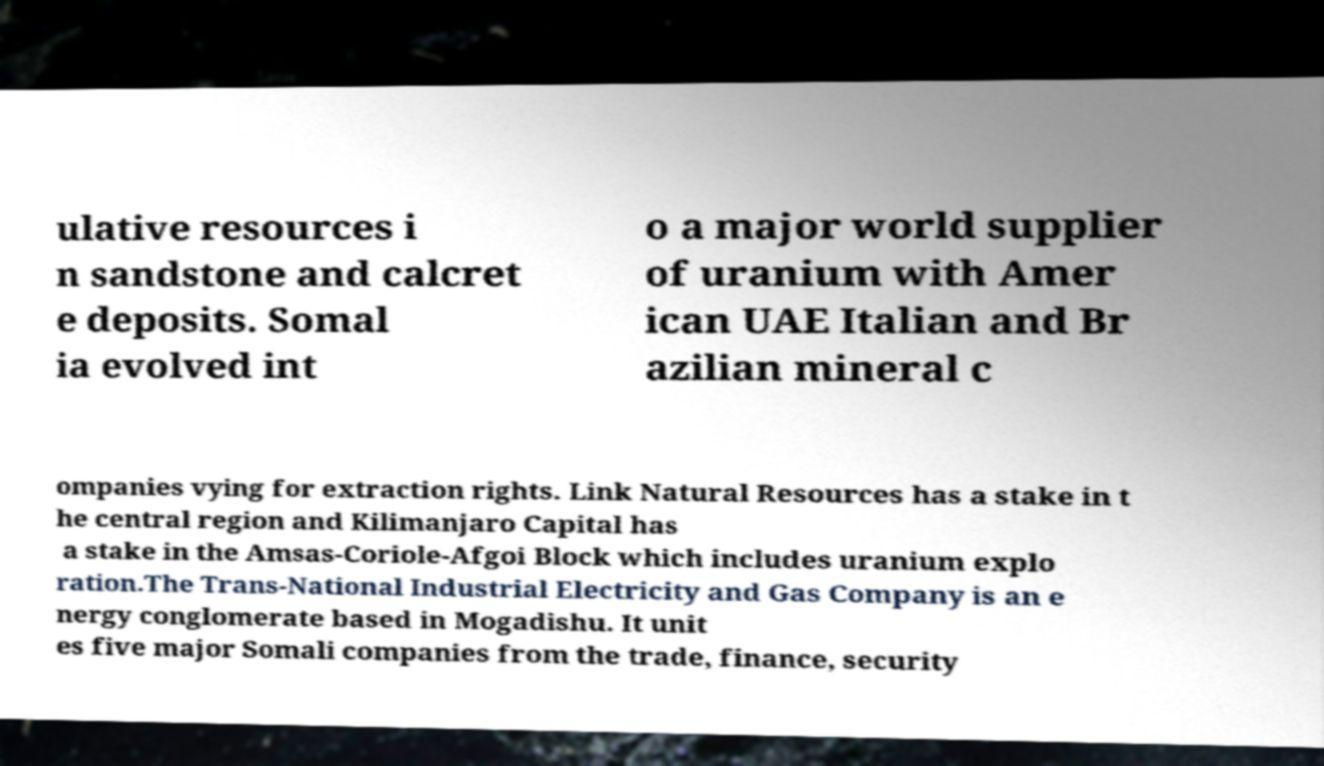Can you accurately transcribe the text from the provided image for me? ulative resources i n sandstone and calcret e deposits. Somal ia evolved int o a major world supplier of uranium with Amer ican UAE Italian and Br azilian mineral c ompanies vying for extraction rights. Link Natural Resources has a stake in t he central region and Kilimanjaro Capital has a stake in the Amsas-Coriole-Afgoi Block which includes uranium explo ration.The Trans-National Industrial Electricity and Gas Company is an e nergy conglomerate based in Mogadishu. It unit es five major Somali companies from the trade, finance, security 